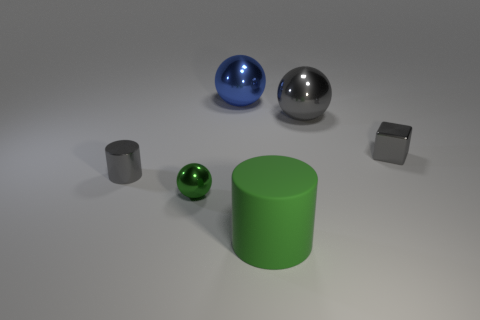Add 3 metal cubes. How many objects exist? 9 Subtract all cylinders. How many objects are left? 4 Subtract all red cylinders. Subtract all green rubber things. How many objects are left? 5 Add 1 tiny gray objects. How many tiny gray objects are left? 3 Add 4 small purple metallic objects. How many small purple metallic objects exist? 4 Subtract 1 gray cylinders. How many objects are left? 5 